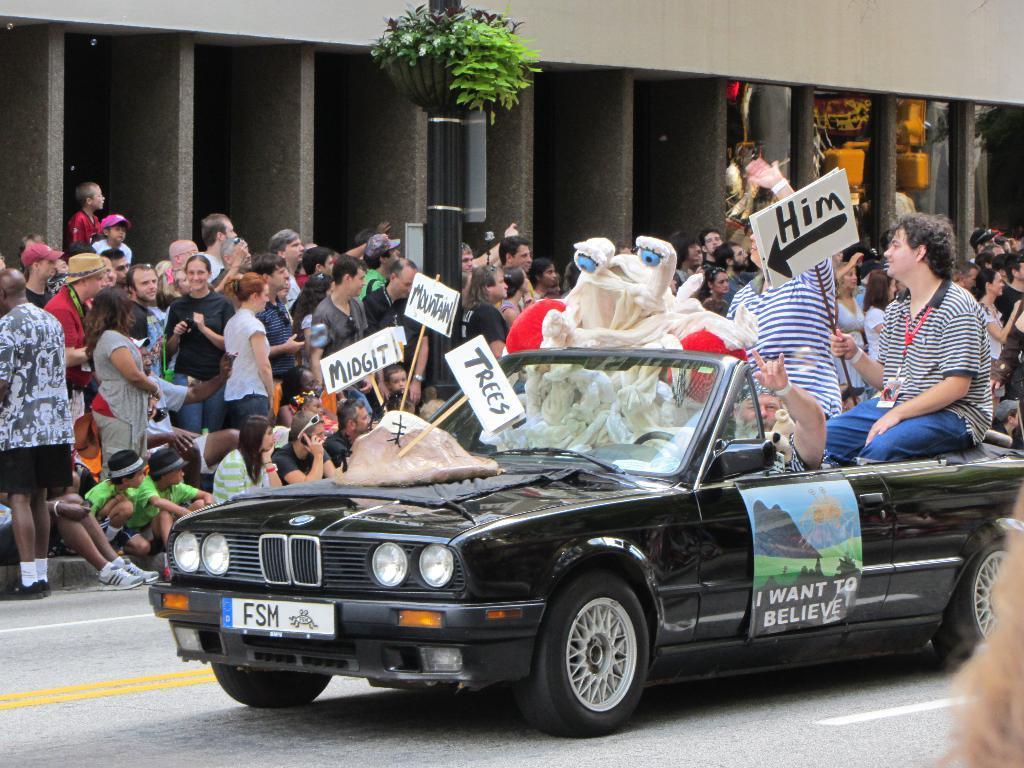How would you summarize this image in a sentence or two? There are lot of people standing in front of the building and and behind them there is a pole with plants on it and few of them are riding car with placards on hand along with cartoon on road. 